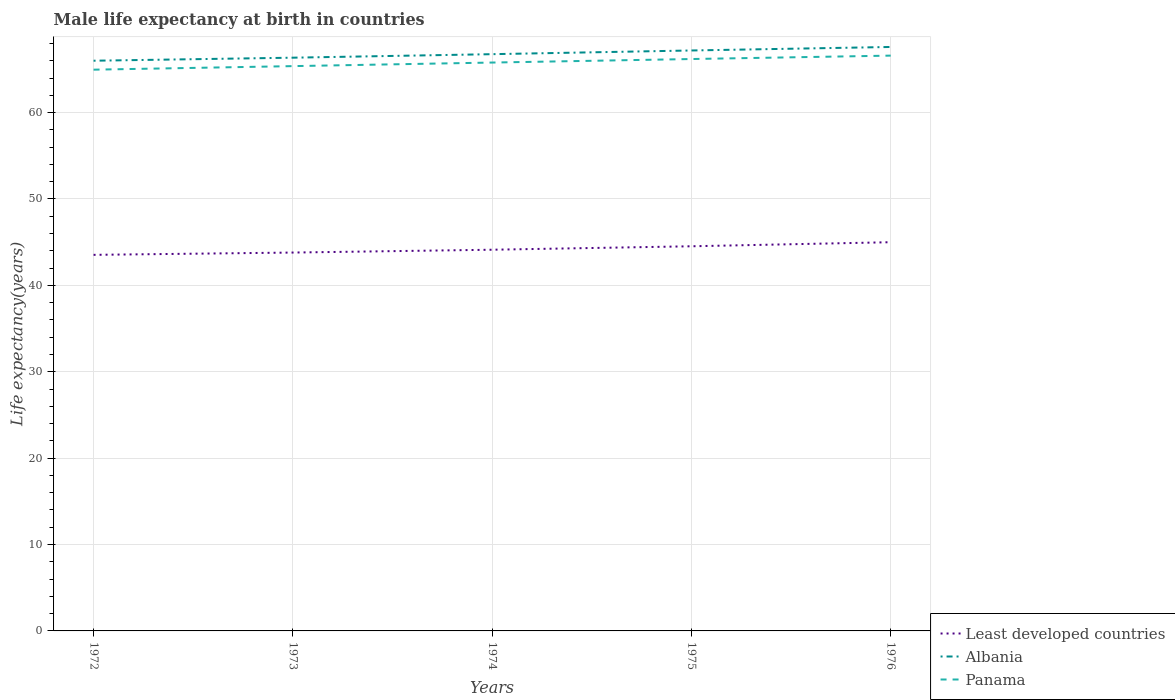How many different coloured lines are there?
Your response must be concise. 3. Is the number of lines equal to the number of legend labels?
Your answer should be compact. Yes. Across all years, what is the maximum male life expectancy at birth in Albania?
Provide a short and direct response. 66. What is the total male life expectancy at birth in Panama in the graph?
Provide a succinct answer. -0.8. What is the difference between the highest and the second highest male life expectancy at birth in Least developed countries?
Offer a very short reply. 1.46. Is the male life expectancy at birth in Panama strictly greater than the male life expectancy at birth in Albania over the years?
Keep it short and to the point. Yes. How many lines are there?
Keep it short and to the point. 3. How many years are there in the graph?
Your response must be concise. 5. What is the difference between two consecutive major ticks on the Y-axis?
Your answer should be very brief. 10. Are the values on the major ticks of Y-axis written in scientific E-notation?
Ensure brevity in your answer.  No. Does the graph contain grids?
Provide a short and direct response. Yes. How many legend labels are there?
Offer a very short reply. 3. What is the title of the graph?
Give a very brief answer. Male life expectancy at birth in countries. What is the label or title of the X-axis?
Provide a succinct answer. Years. What is the label or title of the Y-axis?
Provide a short and direct response. Life expectancy(years). What is the Life expectancy(years) of Least developed countries in 1972?
Ensure brevity in your answer.  43.53. What is the Life expectancy(years) in Albania in 1972?
Your response must be concise. 66. What is the Life expectancy(years) in Panama in 1972?
Ensure brevity in your answer.  64.97. What is the Life expectancy(years) of Least developed countries in 1973?
Give a very brief answer. 43.8. What is the Life expectancy(years) of Albania in 1973?
Your answer should be very brief. 66.36. What is the Life expectancy(years) of Panama in 1973?
Your answer should be very brief. 65.38. What is the Life expectancy(years) of Least developed countries in 1974?
Your answer should be very brief. 44.13. What is the Life expectancy(years) in Albania in 1974?
Your answer should be very brief. 66.76. What is the Life expectancy(years) of Panama in 1974?
Give a very brief answer. 65.79. What is the Life expectancy(years) of Least developed countries in 1975?
Keep it short and to the point. 44.53. What is the Life expectancy(years) of Albania in 1975?
Your response must be concise. 67.19. What is the Life expectancy(years) of Panama in 1975?
Your response must be concise. 66.2. What is the Life expectancy(years) in Least developed countries in 1976?
Make the answer very short. 45. What is the Life expectancy(years) of Albania in 1976?
Your answer should be compact. 67.6. What is the Life expectancy(years) in Panama in 1976?
Give a very brief answer. 66.59. Across all years, what is the maximum Life expectancy(years) of Least developed countries?
Ensure brevity in your answer.  45. Across all years, what is the maximum Life expectancy(years) of Albania?
Provide a short and direct response. 67.6. Across all years, what is the maximum Life expectancy(years) of Panama?
Your response must be concise. 66.59. Across all years, what is the minimum Life expectancy(years) of Least developed countries?
Give a very brief answer. 43.53. Across all years, what is the minimum Life expectancy(years) of Albania?
Provide a succinct answer. 66. Across all years, what is the minimum Life expectancy(years) of Panama?
Keep it short and to the point. 64.97. What is the total Life expectancy(years) of Least developed countries in the graph?
Ensure brevity in your answer.  220.98. What is the total Life expectancy(years) of Albania in the graph?
Your response must be concise. 333.91. What is the total Life expectancy(years) of Panama in the graph?
Your answer should be very brief. 328.93. What is the difference between the Life expectancy(years) of Least developed countries in 1972 and that in 1973?
Your response must be concise. -0.27. What is the difference between the Life expectancy(years) of Albania in 1972 and that in 1973?
Provide a succinct answer. -0.35. What is the difference between the Life expectancy(years) of Panama in 1972 and that in 1973?
Keep it short and to the point. -0.41. What is the difference between the Life expectancy(years) of Least developed countries in 1972 and that in 1974?
Make the answer very short. -0.59. What is the difference between the Life expectancy(years) in Albania in 1972 and that in 1974?
Provide a short and direct response. -0.76. What is the difference between the Life expectancy(years) of Panama in 1972 and that in 1974?
Provide a short and direct response. -0.82. What is the difference between the Life expectancy(years) of Least developed countries in 1972 and that in 1975?
Your answer should be very brief. -0.99. What is the difference between the Life expectancy(years) of Albania in 1972 and that in 1975?
Provide a succinct answer. -1.19. What is the difference between the Life expectancy(years) of Panama in 1972 and that in 1975?
Make the answer very short. -1.23. What is the difference between the Life expectancy(years) in Least developed countries in 1972 and that in 1976?
Provide a succinct answer. -1.46. What is the difference between the Life expectancy(years) in Albania in 1972 and that in 1976?
Keep it short and to the point. -1.59. What is the difference between the Life expectancy(years) of Panama in 1972 and that in 1976?
Offer a terse response. -1.63. What is the difference between the Life expectancy(years) of Least developed countries in 1973 and that in 1974?
Your response must be concise. -0.33. What is the difference between the Life expectancy(years) of Albania in 1973 and that in 1974?
Provide a succinct answer. -0.41. What is the difference between the Life expectancy(years) in Panama in 1973 and that in 1974?
Your answer should be very brief. -0.41. What is the difference between the Life expectancy(years) of Least developed countries in 1973 and that in 1975?
Give a very brief answer. -0.73. What is the difference between the Life expectancy(years) of Albania in 1973 and that in 1975?
Your answer should be compact. -0.83. What is the difference between the Life expectancy(years) of Panama in 1973 and that in 1975?
Give a very brief answer. -0.82. What is the difference between the Life expectancy(years) in Least developed countries in 1973 and that in 1976?
Your response must be concise. -1.2. What is the difference between the Life expectancy(years) in Albania in 1973 and that in 1976?
Your response must be concise. -1.24. What is the difference between the Life expectancy(years) in Panama in 1973 and that in 1976?
Provide a short and direct response. -1.22. What is the difference between the Life expectancy(years) of Least developed countries in 1974 and that in 1975?
Make the answer very short. -0.4. What is the difference between the Life expectancy(years) of Albania in 1974 and that in 1975?
Your answer should be very brief. -0.43. What is the difference between the Life expectancy(years) of Panama in 1974 and that in 1975?
Provide a succinct answer. -0.41. What is the difference between the Life expectancy(years) of Least developed countries in 1974 and that in 1976?
Keep it short and to the point. -0.87. What is the difference between the Life expectancy(years) in Albania in 1974 and that in 1976?
Provide a short and direct response. -0.83. What is the difference between the Life expectancy(years) of Panama in 1974 and that in 1976?
Ensure brevity in your answer.  -0.8. What is the difference between the Life expectancy(years) of Least developed countries in 1975 and that in 1976?
Give a very brief answer. -0.47. What is the difference between the Life expectancy(years) of Albania in 1975 and that in 1976?
Your answer should be very brief. -0.41. What is the difference between the Life expectancy(years) in Panama in 1975 and that in 1976?
Your response must be concise. -0.4. What is the difference between the Life expectancy(years) of Least developed countries in 1972 and the Life expectancy(years) of Albania in 1973?
Give a very brief answer. -22.82. What is the difference between the Life expectancy(years) of Least developed countries in 1972 and the Life expectancy(years) of Panama in 1973?
Make the answer very short. -21.85. What is the difference between the Life expectancy(years) of Albania in 1972 and the Life expectancy(years) of Panama in 1973?
Your response must be concise. 0.62. What is the difference between the Life expectancy(years) of Least developed countries in 1972 and the Life expectancy(years) of Albania in 1974?
Provide a short and direct response. -23.23. What is the difference between the Life expectancy(years) of Least developed countries in 1972 and the Life expectancy(years) of Panama in 1974?
Provide a short and direct response. -22.26. What is the difference between the Life expectancy(years) of Albania in 1972 and the Life expectancy(years) of Panama in 1974?
Keep it short and to the point. 0.21. What is the difference between the Life expectancy(years) in Least developed countries in 1972 and the Life expectancy(years) in Albania in 1975?
Ensure brevity in your answer.  -23.66. What is the difference between the Life expectancy(years) in Least developed countries in 1972 and the Life expectancy(years) in Panama in 1975?
Your response must be concise. -22.67. What is the difference between the Life expectancy(years) in Albania in 1972 and the Life expectancy(years) in Panama in 1975?
Keep it short and to the point. -0.2. What is the difference between the Life expectancy(years) in Least developed countries in 1972 and the Life expectancy(years) in Albania in 1976?
Offer a very short reply. -24.06. What is the difference between the Life expectancy(years) in Least developed countries in 1972 and the Life expectancy(years) in Panama in 1976?
Offer a very short reply. -23.06. What is the difference between the Life expectancy(years) in Albania in 1972 and the Life expectancy(years) in Panama in 1976?
Make the answer very short. -0.59. What is the difference between the Life expectancy(years) in Least developed countries in 1973 and the Life expectancy(years) in Albania in 1974?
Offer a very short reply. -22.96. What is the difference between the Life expectancy(years) in Least developed countries in 1973 and the Life expectancy(years) in Panama in 1974?
Your answer should be very brief. -21.99. What is the difference between the Life expectancy(years) of Albania in 1973 and the Life expectancy(years) of Panama in 1974?
Your response must be concise. 0.56. What is the difference between the Life expectancy(years) of Least developed countries in 1973 and the Life expectancy(years) of Albania in 1975?
Ensure brevity in your answer.  -23.39. What is the difference between the Life expectancy(years) in Least developed countries in 1973 and the Life expectancy(years) in Panama in 1975?
Your answer should be compact. -22.4. What is the difference between the Life expectancy(years) of Albania in 1973 and the Life expectancy(years) of Panama in 1975?
Give a very brief answer. 0.16. What is the difference between the Life expectancy(years) of Least developed countries in 1973 and the Life expectancy(years) of Albania in 1976?
Your answer should be compact. -23.8. What is the difference between the Life expectancy(years) of Least developed countries in 1973 and the Life expectancy(years) of Panama in 1976?
Provide a short and direct response. -22.8. What is the difference between the Life expectancy(years) of Albania in 1973 and the Life expectancy(years) of Panama in 1976?
Keep it short and to the point. -0.24. What is the difference between the Life expectancy(years) of Least developed countries in 1974 and the Life expectancy(years) of Albania in 1975?
Offer a very short reply. -23.06. What is the difference between the Life expectancy(years) of Least developed countries in 1974 and the Life expectancy(years) of Panama in 1975?
Keep it short and to the point. -22.07. What is the difference between the Life expectancy(years) of Albania in 1974 and the Life expectancy(years) of Panama in 1975?
Give a very brief answer. 0.56. What is the difference between the Life expectancy(years) of Least developed countries in 1974 and the Life expectancy(years) of Albania in 1976?
Ensure brevity in your answer.  -23.47. What is the difference between the Life expectancy(years) of Least developed countries in 1974 and the Life expectancy(years) of Panama in 1976?
Offer a very short reply. -22.47. What is the difference between the Life expectancy(years) of Albania in 1974 and the Life expectancy(years) of Panama in 1976?
Ensure brevity in your answer.  0.17. What is the difference between the Life expectancy(years) in Least developed countries in 1975 and the Life expectancy(years) in Albania in 1976?
Your answer should be very brief. -23.07. What is the difference between the Life expectancy(years) of Least developed countries in 1975 and the Life expectancy(years) of Panama in 1976?
Offer a very short reply. -22.07. What is the difference between the Life expectancy(years) of Albania in 1975 and the Life expectancy(years) of Panama in 1976?
Give a very brief answer. 0.59. What is the average Life expectancy(years) in Least developed countries per year?
Ensure brevity in your answer.  44.2. What is the average Life expectancy(years) of Albania per year?
Keep it short and to the point. 66.78. What is the average Life expectancy(years) in Panama per year?
Your answer should be compact. 65.79. In the year 1972, what is the difference between the Life expectancy(years) in Least developed countries and Life expectancy(years) in Albania?
Ensure brevity in your answer.  -22.47. In the year 1972, what is the difference between the Life expectancy(years) of Least developed countries and Life expectancy(years) of Panama?
Offer a terse response. -21.44. In the year 1972, what is the difference between the Life expectancy(years) of Albania and Life expectancy(years) of Panama?
Give a very brief answer. 1.04. In the year 1973, what is the difference between the Life expectancy(years) of Least developed countries and Life expectancy(years) of Albania?
Your answer should be compact. -22.56. In the year 1973, what is the difference between the Life expectancy(years) of Least developed countries and Life expectancy(years) of Panama?
Offer a terse response. -21.58. In the year 1973, what is the difference between the Life expectancy(years) in Albania and Life expectancy(years) in Panama?
Keep it short and to the point. 0.98. In the year 1974, what is the difference between the Life expectancy(years) in Least developed countries and Life expectancy(years) in Albania?
Offer a very short reply. -22.64. In the year 1974, what is the difference between the Life expectancy(years) in Least developed countries and Life expectancy(years) in Panama?
Your response must be concise. -21.67. In the year 1974, what is the difference between the Life expectancy(years) of Albania and Life expectancy(years) of Panama?
Offer a terse response. 0.97. In the year 1975, what is the difference between the Life expectancy(years) in Least developed countries and Life expectancy(years) in Albania?
Give a very brief answer. -22.66. In the year 1975, what is the difference between the Life expectancy(years) in Least developed countries and Life expectancy(years) in Panama?
Your answer should be very brief. -21.67. In the year 1976, what is the difference between the Life expectancy(years) of Least developed countries and Life expectancy(years) of Albania?
Make the answer very short. -22.6. In the year 1976, what is the difference between the Life expectancy(years) in Least developed countries and Life expectancy(years) in Panama?
Your answer should be very brief. -21.6. What is the ratio of the Life expectancy(years) in Least developed countries in 1972 to that in 1973?
Keep it short and to the point. 0.99. What is the ratio of the Life expectancy(years) in Albania in 1972 to that in 1973?
Offer a terse response. 0.99. What is the ratio of the Life expectancy(years) in Least developed countries in 1972 to that in 1974?
Your answer should be compact. 0.99. What is the ratio of the Life expectancy(years) in Panama in 1972 to that in 1974?
Your response must be concise. 0.99. What is the ratio of the Life expectancy(years) of Least developed countries in 1972 to that in 1975?
Ensure brevity in your answer.  0.98. What is the ratio of the Life expectancy(years) of Albania in 1972 to that in 1975?
Ensure brevity in your answer.  0.98. What is the ratio of the Life expectancy(years) of Panama in 1972 to that in 1975?
Your answer should be very brief. 0.98. What is the ratio of the Life expectancy(years) in Least developed countries in 1972 to that in 1976?
Your response must be concise. 0.97. What is the ratio of the Life expectancy(years) of Albania in 1972 to that in 1976?
Your answer should be compact. 0.98. What is the ratio of the Life expectancy(years) of Panama in 1972 to that in 1976?
Provide a succinct answer. 0.98. What is the ratio of the Life expectancy(years) in Least developed countries in 1973 to that in 1975?
Provide a succinct answer. 0.98. What is the ratio of the Life expectancy(years) in Albania in 1973 to that in 1975?
Offer a very short reply. 0.99. What is the ratio of the Life expectancy(years) in Panama in 1973 to that in 1975?
Offer a terse response. 0.99. What is the ratio of the Life expectancy(years) of Least developed countries in 1973 to that in 1976?
Keep it short and to the point. 0.97. What is the ratio of the Life expectancy(years) in Albania in 1973 to that in 1976?
Ensure brevity in your answer.  0.98. What is the ratio of the Life expectancy(years) of Panama in 1973 to that in 1976?
Ensure brevity in your answer.  0.98. What is the ratio of the Life expectancy(years) of Least developed countries in 1974 to that in 1975?
Provide a short and direct response. 0.99. What is the ratio of the Life expectancy(years) of Albania in 1974 to that in 1975?
Keep it short and to the point. 0.99. What is the ratio of the Life expectancy(years) of Least developed countries in 1974 to that in 1976?
Give a very brief answer. 0.98. What is the ratio of the Life expectancy(years) of Panama in 1974 to that in 1976?
Provide a succinct answer. 0.99. What is the ratio of the Life expectancy(years) of Albania in 1975 to that in 1976?
Keep it short and to the point. 0.99. What is the ratio of the Life expectancy(years) in Panama in 1975 to that in 1976?
Offer a very short reply. 0.99. What is the difference between the highest and the second highest Life expectancy(years) of Least developed countries?
Provide a succinct answer. 0.47. What is the difference between the highest and the second highest Life expectancy(years) of Albania?
Offer a very short reply. 0.41. What is the difference between the highest and the second highest Life expectancy(years) in Panama?
Your answer should be compact. 0.4. What is the difference between the highest and the lowest Life expectancy(years) of Least developed countries?
Your response must be concise. 1.46. What is the difference between the highest and the lowest Life expectancy(years) in Albania?
Your answer should be very brief. 1.59. What is the difference between the highest and the lowest Life expectancy(years) of Panama?
Your answer should be compact. 1.63. 